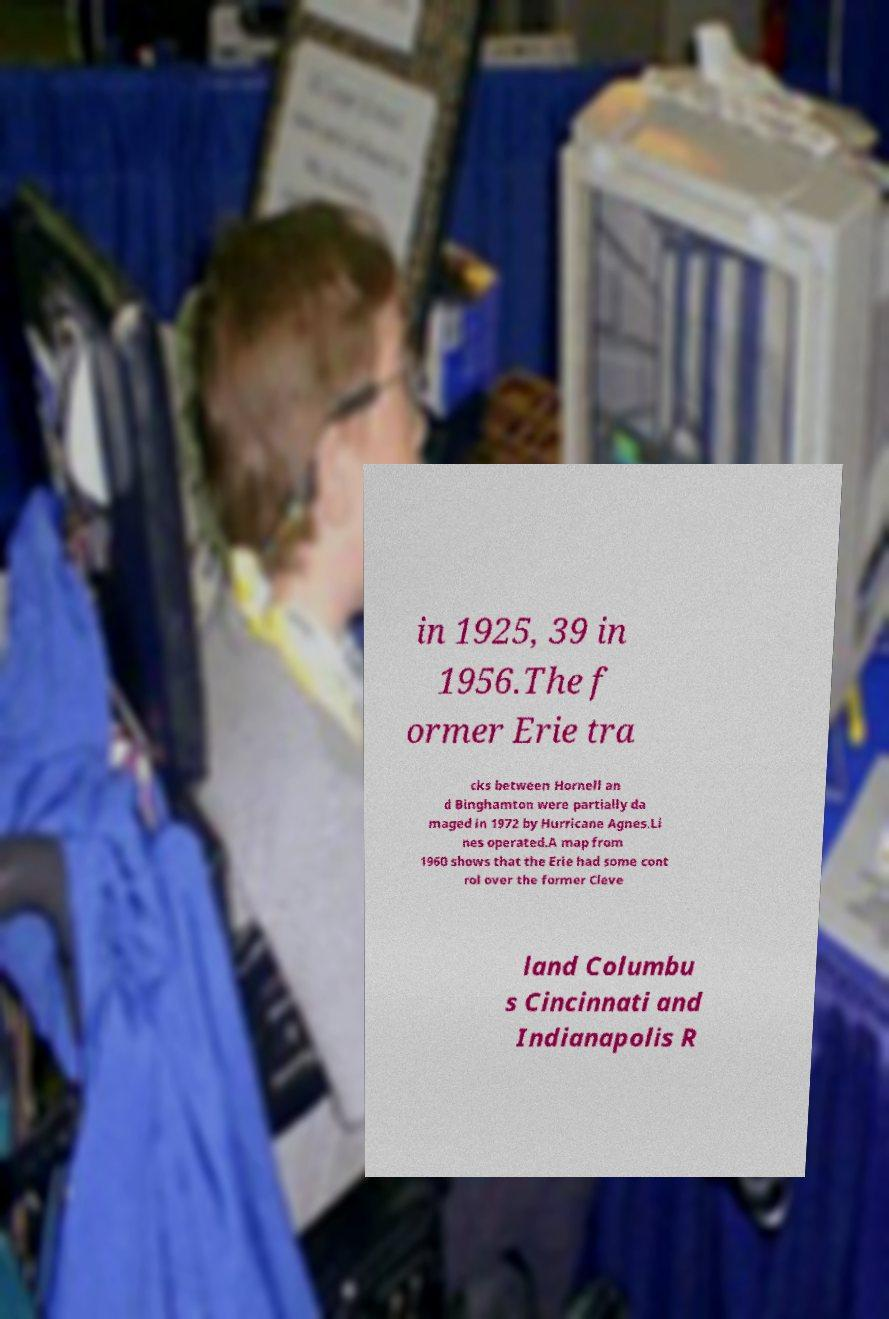Could you extract and type out the text from this image? in 1925, 39 in 1956.The f ormer Erie tra cks between Hornell an d Binghamton were partially da maged in 1972 by Hurricane Agnes.Li nes operated.A map from 1960 shows that the Erie had some cont rol over the former Cleve land Columbu s Cincinnati and Indianapolis R 